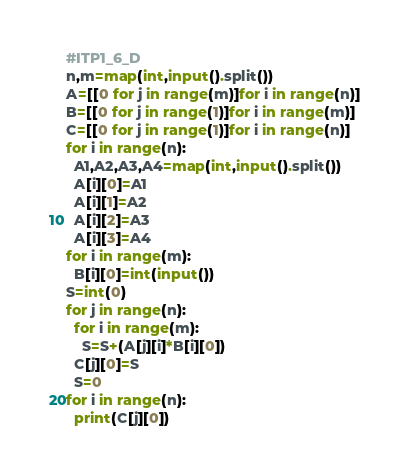<code> <loc_0><loc_0><loc_500><loc_500><_Python_>#ITP1_6_D
n,m=map(int,input().split())
A=[[0 for j in range(m)]for i in range(n)]
B=[[0 for j in range(1)]for i in range(m)]
C=[[0 for j in range(1)]for i in range(n)]
for i in range(n):
  A1,A2,A3,A4=map(int,input().split())
  A[i][0]=A1
  A[i][1]=A2
  A[i][2]=A3
  A[i][3]=A4
for i in range(m):
  B[i][0]=int(input())
S=int(0)
for j in range(n):
  for i in range(m):
    S=S+(A[j][i]*B[i][0])
  C[j][0]=S
  S=0
for i in range(n):
  print(C[j][0])

</code> 